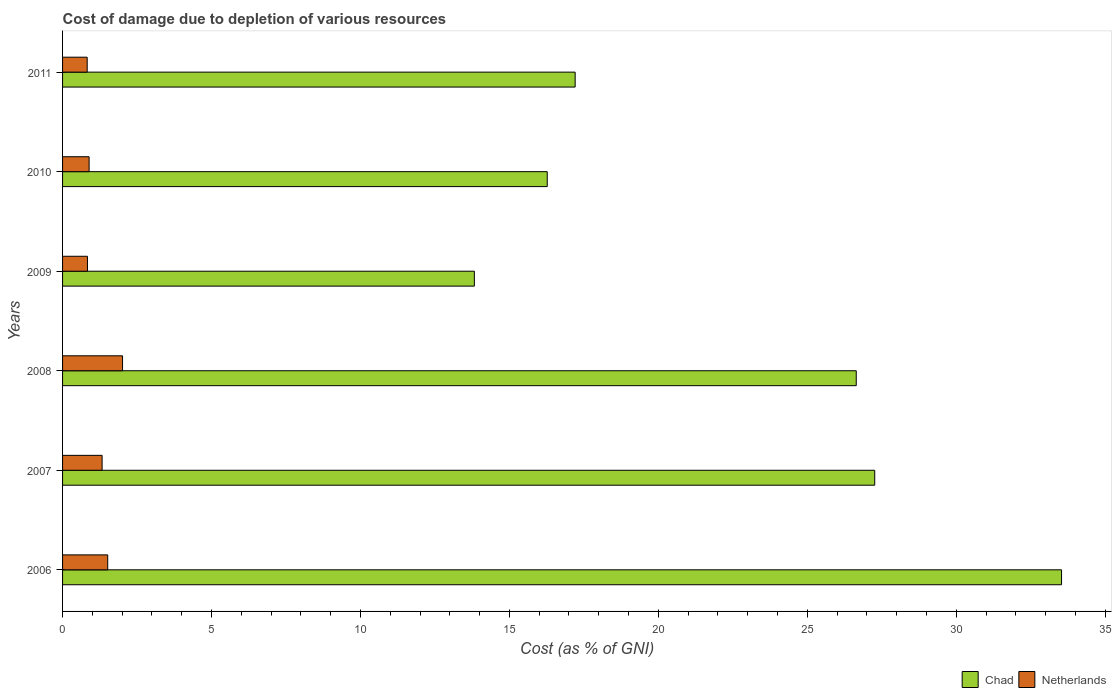How many groups of bars are there?
Offer a very short reply. 6. Are the number of bars per tick equal to the number of legend labels?
Keep it short and to the point. Yes. Are the number of bars on each tick of the Y-axis equal?
Make the answer very short. Yes. How many bars are there on the 6th tick from the top?
Your response must be concise. 2. How many bars are there on the 3rd tick from the bottom?
Keep it short and to the point. 2. What is the cost of damage caused due to the depletion of various resources in Chad in 2006?
Make the answer very short. 33.53. Across all years, what is the maximum cost of damage caused due to the depletion of various resources in Chad?
Your response must be concise. 33.53. Across all years, what is the minimum cost of damage caused due to the depletion of various resources in Netherlands?
Provide a short and direct response. 0.83. In which year was the cost of damage caused due to the depletion of various resources in Chad maximum?
Ensure brevity in your answer.  2006. What is the total cost of damage caused due to the depletion of various resources in Netherlands in the graph?
Provide a succinct answer. 7.41. What is the difference between the cost of damage caused due to the depletion of various resources in Netherlands in 2008 and that in 2009?
Your response must be concise. 1.18. What is the difference between the cost of damage caused due to the depletion of various resources in Chad in 2006 and the cost of damage caused due to the depletion of various resources in Netherlands in 2009?
Give a very brief answer. 32.7. What is the average cost of damage caused due to the depletion of various resources in Chad per year?
Offer a very short reply. 22.46. In the year 2010, what is the difference between the cost of damage caused due to the depletion of various resources in Chad and cost of damage caused due to the depletion of various resources in Netherlands?
Give a very brief answer. 15.38. What is the ratio of the cost of damage caused due to the depletion of various resources in Netherlands in 2006 to that in 2010?
Offer a terse response. 1.7. What is the difference between the highest and the second highest cost of damage caused due to the depletion of various resources in Netherlands?
Provide a succinct answer. 0.5. What is the difference between the highest and the lowest cost of damage caused due to the depletion of various resources in Chad?
Give a very brief answer. 19.71. What does the 2nd bar from the top in 2008 represents?
Keep it short and to the point. Chad. What does the 1st bar from the bottom in 2010 represents?
Ensure brevity in your answer.  Chad. How many years are there in the graph?
Your answer should be very brief. 6. What is the difference between two consecutive major ticks on the X-axis?
Make the answer very short. 5. Does the graph contain any zero values?
Offer a very short reply. No. Where does the legend appear in the graph?
Your response must be concise. Bottom right. How many legend labels are there?
Give a very brief answer. 2. How are the legend labels stacked?
Offer a very short reply. Horizontal. What is the title of the graph?
Offer a very short reply. Cost of damage due to depletion of various resources. What is the label or title of the X-axis?
Make the answer very short. Cost (as % of GNI). What is the Cost (as % of GNI) of Chad in 2006?
Provide a succinct answer. 33.53. What is the Cost (as % of GNI) in Netherlands in 2006?
Keep it short and to the point. 1.52. What is the Cost (as % of GNI) of Chad in 2007?
Your answer should be compact. 27.26. What is the Cost (as % of GNI) of Netherlands in 2007?
Your answer should be compact. 1.33. What is the Cost (as % of GNI) in Chad in 2008?
Give a very brief answer. 26.64. What is the Cost (as % of GNI) of Netherlands in 2008?
Offer a very short reply. 2.01. What is the Cost (as % of GNI) in Chad in 2009?
Your answer should be compact. 13.82. What is the Cost (as % of GNI) of Netherlands in 2009?
Provide a short and direct response. 0.84. What is the Cost (as % of GNI) in Chad in 2010?
Offer a terse response. 16.27. What is the Cost (as % of GNI) in Netherlands in 2010?
Ensure brevity in your answer.  0.89. What is the Cost (as % of GNI) of Chad in 2011?
Your answer should be compact. 17.21. What is the Cost (as % of GNI) of Netherlands in 2011?
Your answer should be compact. 0.83. Across all years, what is the maximum Cost (as % of GNI) of Chad?
Make the answer very short. 33.53. Across all years, what is the maximum Cost (as % of GNI) of Netherlands?
Provide a short and direct response. 2.01. Across all years, what is the minimum Cost (as % of GNI) of Chad?
Keep it short and to the point. 13.82. Across all years, what is the minimum Cost (as % of GNI) of Netherlands?
Ensure brevity in your answer.  0.83. What is the total Cost (as % of GNI) of Chad in the graph?
Keep it short and to the point. 134.74. What is the total Cost (as % of GNI) in Netherlands in the graph?
Offer a very short reply. 7.41. What is the difference between the Cost (as % of GNI) in Chad in 2006 and that in 2007?
Give a very brief answer. 6.27. What is the difference between the Cost (as % of GNI) in Netherlands in 2006 and that in 2007?
Provide a short and direct response. 0.19. What is the difference between the Cost (as % of GNI) of Chad in 2006 and that in 2008?
Make the answer very short. 6.89. What is the difference between the Cost (as % of GNI) in Netherlands in 2006 and that in 2008?
Make the answer very short. -0.5. What is the difference between the Cost (as % of GNI) in Chad in 2006 and that in 2009?
Your answer should be compact. 19.71. What is the difference between the Cost (as % of GNI) in Netherlands in 2006 and that in 2009?
Offer a very short reply. 0.68. What is the difference between the Cost (as % of GNI) of Chad in 2006 and that in 2010?
Provide a succinct answer. 17.26. What is the difference between the Cost (as % of GNI) of Netherlands in 2006 and that in 2010?
Your response must be concise. 0.62. What is the difference between the Cost (as % of GNI) of Chad in 2006 and that in 2011?
Give a very brief answer. 16.33. What is the difference between the Cost (as % of GNI) of Netherlands in 2006 and that in 2011?
Give a very brief answer. 0.69. What is the difference between the Cost (as % of GNI) of Chad in 2007 and that in 2008?
Give a very brief answer. 0.62. What is the difference between the Cost (as % of GNI) in Netherlands in 2007 and that in 2008?
Your answer should be compact. -0.69. What is the difference between the Cost (as % of GNI) in Chad in 2007 and that in 2009?
Make the answer very short. 13.44. What is the difference between the Cost (as % of GNI) in Netherlands in 2007 and that in 2009?
Make the answer very short. 0.49. What is the difference between the Cost (as % of GNI) in Chad in 2007 and that in 2010?
Provide a succinct answer. 10.99. What is the difference between the Cost (as % of GNI) of Netherlands in 2007 and that in 2010?
Offer a terse response. 0.44. What is the difference between the Cost (as % of GNI) of Chad in 2007 and that in 2011?
Offer a very short reply. 10.06. What is the difference between the Cost (as % of GNI) of Netherlands in 2007 and that in 2011?
Your answer should be compact. 0.5. What is the difference between the Cost (as % of GNI) in Chad in 2008 and that in 2009?
Your answer should be compact. 12.82. What is the difference between the Cost (as % of GNI) of Netherlands in 2008 and that in 2009?
Make the answer very short. 1.18. What is the difference between the Cost (as % of GNI) of Chad in 2008 and that in 2010?
Your answer should be compact. 10.37. What is the difference between the Cost (as % of GNI) of Netherlands in 2008 and that in 2010?
Provide a succinct answer. 1.12. What is the difference between the Cost (as % of GNI) of Chad in 2008 and that in 2011?
Provide a succinct answer. 9.44. What is the difference between the Cost (as % of GNI) in Netherlands in 2008 and that in 2011?
Offer a very short reply. 1.19. What is the difference between the Cost (as % of GNI) in Chad in 2009 and that in 2010?
Your answer should be very brief. -2.45. What is the difference between the Cost (as % of GNI) in Netherlands in 2009 and that in 2010?
Your response must be concise. -0.06. What is the difference between the Cost (as % of GNI) in Chad in 2009 and that in 2011?
Give a very brief answer. -3.38. What is the difference between the Cost (as % of GNI) of Netherlands in 2009 and that in 2011?
Your answer should be compact. 0.01. What is the difference between the Cost (as % of GNI) in Chad in 2010 and that in 2011?
Your answer should be compact. -0.94. What is the difference between the Cost (as % of GNI) of Netherlands in 2010 and that in 2011?
Ensure brevity in your answer.  0.06. What is the difference between the Cost (as % of GNI) in Chad in 2006 and the Cost (as % of GNI) in Netherlands in 2007?
Your answer should be very brief. 32.21. What is the difference between the Cost (as % of GNI) in Chad in 2006 and the Cost (as % of GNI) in Netherlands in 2008?
Ensure brevity in your answer.  31.52. What is the difference between the Cost (as % of GNI) of Chad in 2006 and the Cost (as % of GNI) of Netherlands in 2009?
Ensure brevity in your answer.  32.7. What is the difference between the Cost (as % of GNI) in Chad in 2006 and the Cost (as % of GNI) in Netherlands in 2010?
Ensure brevity in your answer.  32.64. What is the difference between the Cost (as % of GNI) of Chad in 2006 and the Cost (as % of GNI) of Netherlands in 2011?
Ensure brevity in your answer.  32.71. What is the difference between the Cost (as % of GNI) in Chad in 2007 and the Cost (as % of GNI) in Netherlands in 2008?
Offer a very short reply. 25.25. What is the difference between the Cost (as % of GNI) of Chad in 2007 and the Cost (as % of GNI) of Netherlands in 2009?
Your response must be concise. 26.43. What is the difference between the Cost (as % of GNI) of Chad in 2007 and the Cost (as % of GNI) of Netherlands in 2010?
Offer a terse response. 26.37. What is the difference between the Cost (as % of GNI) in Chad in 2007 and the Cost (as % of GNI) in Netherlands in 2011?
Provide a short and direct response. 26.44. What is the difference between the Cost (as % of GNI) of Chad in 2008 and the Cost (as % of GNI) of Netherlands in 2009?
Offer a very short reply. 25.81. What is the difference between the Cost (as % of GNI) of Chad in 2008 and the Cost (as % of GNI) of Netherlands in 2010?
Give a very brief answer. 25.75. What is the difference between the Cost (as % of GNI) of Chad in 2008 and the Cost (as % of GNI) of Netherlands in 2011?
Give a very brief answer. 25.82. What is the difference between the Cost (as % of GNI) of Chad in 2009 and the Cost (as % of GNI) of Netherlands in 2010?
Keep it short and to the point. 12.93. What is the difference between the Cost (as % of GNI) in Chad in 2009 and the Cost (as % of GNI) in Netherlands in 2011?
Your answer should be very brief. 13. What is the difference between the Cost (as % of GNI) of Chad in 2010 and the Cost (as % of GNI) of Netherlands in 2011?
Your response must be concise. 15.44. What is the average Cost (as % of GNI) of Chad per year?
Offer a very short reply. 22.46. What is the average Cost (as % of GNI) in Netherlands per year?
Your answer should be very brief. 1.24. In the year 2006, what is the difference between the Cost (as % of GNI) in Chad and Cost (as % of GNI) in Netherlands?
Ensure brevity in your answer.  32.02. In the year 2007, what is the difference between the Cost (as % of GNI) of Chad and Cost (as % of GNI) of Netherlands?
Your answer should be compact. 25.94. In the year 2008, what is the difference between the Cost (as % of GNI) of Chad and Cost (as % of GNI) of Netherlands?
Ensure brevity in your answer.  24.63. In the year 2009, what is the difference between the Cost (as % of GNI) of Chad and Cost (as % of GNI) of Netherlands?
Keep it short and to the point. 12.99. In the year 2010, what is the difference between the Cost (as % of GNI) of Chad and Cost (as % of GNI) of Netherlands?
Give a very brief answer. 15.38. In the year 2011, what is the difference between the Cost (as % of GNI) of Chad and Cost (as % of GNI) of Netherlands?
Ensure brevity in your answer.  16.38. What is the ratio of the Cost (as % of GNI) of Chad in 2006 to that in 2007?
Your answer should be very brief. 1.23. What is the ratio of the Cost (as % of GNI) in Netherlands in 2006 to that in 2007?
Offer a very short reply. 1.14. What is the ratio of the Cost (as % of GNI) in Chad in 2006 to that in 2008?
Provide a short and direct response. 1.26. What is the ratio of the Cost (as % of GNI) of Netherlands in 2006 to that in 2008?
Your answer should be compact. 0.75. What is the ratio of the Cost (as % of GNI) of Chad in 2006 to that in 2009?
Offer a terse response. 2.43. What is the ratio of the Cost (as % of GNI) of Netherlands in 2006 to that in 2009?
Give a very brief answer. 1.81. What is the ratio of the Cost (as % of GNI) of Chad in 2006 to that in 2010?
Keep it short and to the point. 2.06. What is the ratio of the Cost (as % of GNI) of Netherlands in 2006 to that in 2010?
Your answer should be very brief. 1.7. What is the ratio of the Cost (as % of GNI) in Chad in 2006 to that in 2011?
Provide a short and direct response. 1.95. What is the ratio of the Cost (as % of GNI) in Netherlands in 2006 to that in 2011?
Your response must be concise. 1.83. What is the ratio of the Cost (as % of GNI) of Chad in 2007 to that in 2008?
Give a very brief answer. 1.02. What is the ratio of the Cost (as % of GNI) of Netherlands in 2007 to that in 2008?
Ensure brevity in your answer.  0.66. What is the ratio of the Cost (as % of GNI) in Chad in 2007 to that in 2009?
Provide a short and direct response. 1.97. What is the ratio of the Cost (as % of GNI) of Netherlands in 2007 to that in 2009?
Provide a short and direct response. 1.59. What is the ratio of the Cost (as % of GNI) in Chad in 2007 to that in 2010?
Your answer should be compact. 1.68. What is the ratio of the Cost (as % of GNI) of Netherlands in 2007 to that in 2010?
Provide a succinct answer. 1.49. What is the ratio of the Cost (as % of GNI) in Chad in 2007 to that in 2011?
Provide a short and direct response. 1.58. What is the ratio of the Cost (as % of GNI) in Netherlands in 2007 to that in 2011?
Ensure brevity in your answer.  1.61. What is the ratio of the Cost (as % of GNI) in Chad in 2008 to that in 2009?
Ensure brevity in your answer.  1.93. What is the ratio of the Cost (as % of GNI) of Netherlands in 2008 to that in 2009?
Your response must be concise. 2.41. What is the ratio of the Cost (as % of GNI) of Chad in 2008 to that in 2010?
Your response must be concise. 1.64. What is the ratio of the Cost (as % of GNI) in Netherlands in 2008 to that in 2010?
Ensure brevity in your answer.  2.26. What is the ratio of the Cost (as % of GNI) of Chad in 2008 to that in 2011?
Provide a short and direct response. 1.55. What is the ratio of the Cost (as % of GNI) in Netherlands in 2008 to that in 2011?
Provide a short and direct response. 2.44. What is the ratio of the Cost (as % of GNI) in Chad in 2009 to that in 2010?
Offer a terse response. 0.85. What is the ratio of the Cost (as % of GNI) in Netherlands in 2009 to that in 2010?
Your answer should be very brief. 0.94. What is the ratio of the Cost (as % of GNI) in Chad in 2009 to that in 2011?
Offer a terse response. 0.8. What is the ratio of the Cost (as % of GNI) in Netherlands in 2009 to that in 2011?
Offer a very short reply. 1.01. What is the ratio of the Cost (as % of GNI) in Chad in 2010 to that in 2011?
Provide a succinct answer. 0.95. What is the ratio of the Cost (as % of GNI) of Netherlands in 2010 to that in 2011?
Provide a succinct answer. 1.08. What is the difference between the highest and the second highest Cost (as % of GNI) in Chad?
Your response must be concise. 6.27. What is the difference between the highest and the second highest Cost (as % of GNI) in Netherlands?
Your response must be concise. 0.5. What is the difference between the highest and the lowest Cost (as % of GNI) in Chad?
Provide a short and direct response. 19.71. What is the difference between the highest and the lowest Cost (as % of GNI) of Netherlands?
Offer a very short reply. 1.19. 